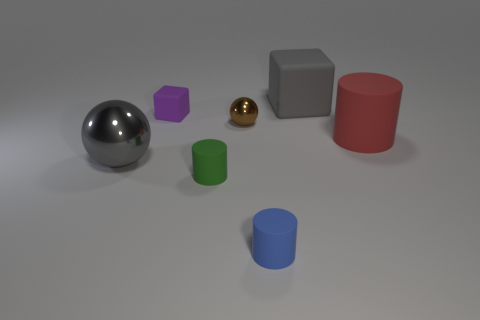Subtract all small green cylinders. How many cylinders are left? 2 Subtract 1 cylinders. How many cylinders are left? 2 Add 3 small blue matte objects. How many objects exist? 10 Subtract all cylinders. How many objects are left? 4 Add 5 small brown metallic spheres. How many small brown metallic spheres exist? 6 Subtract 1 green cylinders. How many objects are left? 6 Subtract all small red balls. Subtract all large matte cylinders. How many objects are left? 6 Add 5 tiny cylinders. How many tiny cylinders are left? 7 